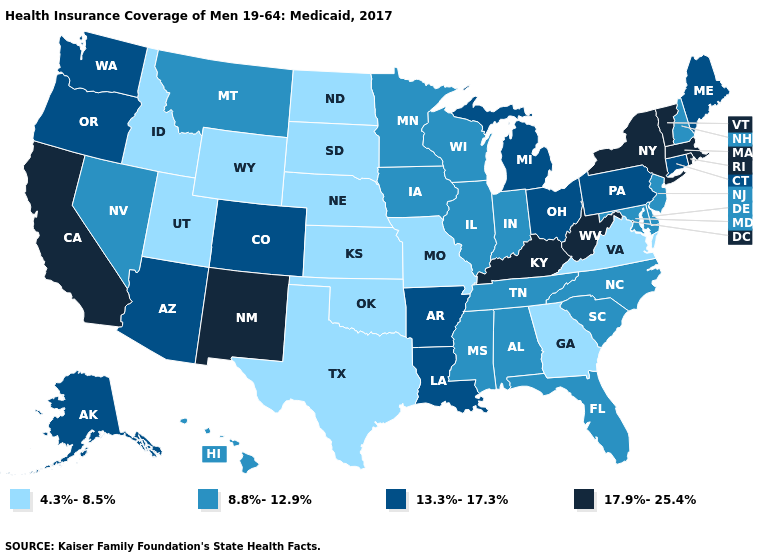Which states have the lowest value in the MidWest?
Keep it brief. Kansas, Missouri, Nebraska, North Dakota, South Dakota. Name the states that have a value in the range 4.3%-8.5%?
Answer briefly. Georgia, Idaho, Kansas, Missouri, Nebraska, North Dakota, Oklahoma, South Dakota, Texas, Utah, Virginia, Wyoming. Does New York have the highest value in the USA?
Give a very brief answer. Yes. What is the lowest value in the USA?
Short answer required. 4.3%-8.5%. What is the value of Vermont?
Be succinct. 17.9%-25.4%. What is the value of Oregon?
Give a very brief answer. 13.3%-17.3%. Does Florida have a higher value than Texas?
Be succinct. Yes. Which states hav the highest value in the South?
Keep it brief. Kentucky, West Virginia. What is the lowest value in the Northeast?
Quick response, please. 8.8%-12.9%. Name the states that have a value in the range 13.3%-17.3%?
Be succinct. Alaska, Arizona, Arkansas, Colorado, Connecticut, Louisiana, Maine, Michigan, Ohio, Oregon, Pennsylvania, Washington. How many symbols are there in the legend?
Give a very brief answer. 4. Among the states that border Oregon , does California have the highest value?
Be succinct. Yes. What is the value of Wyoming?
Give a very brief answer. 4.3%-8.5%. What is the lowest value in the Northeast?
Quick response, please. 8.8%-12.9%. What is the value of Montana?
Quick response, please. 8.8%-12.9%. 